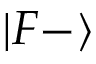Convert formula to latex. <formula><loc_0><loc_0><loc_500><loc_500>| F { - } \rangle</formula> 